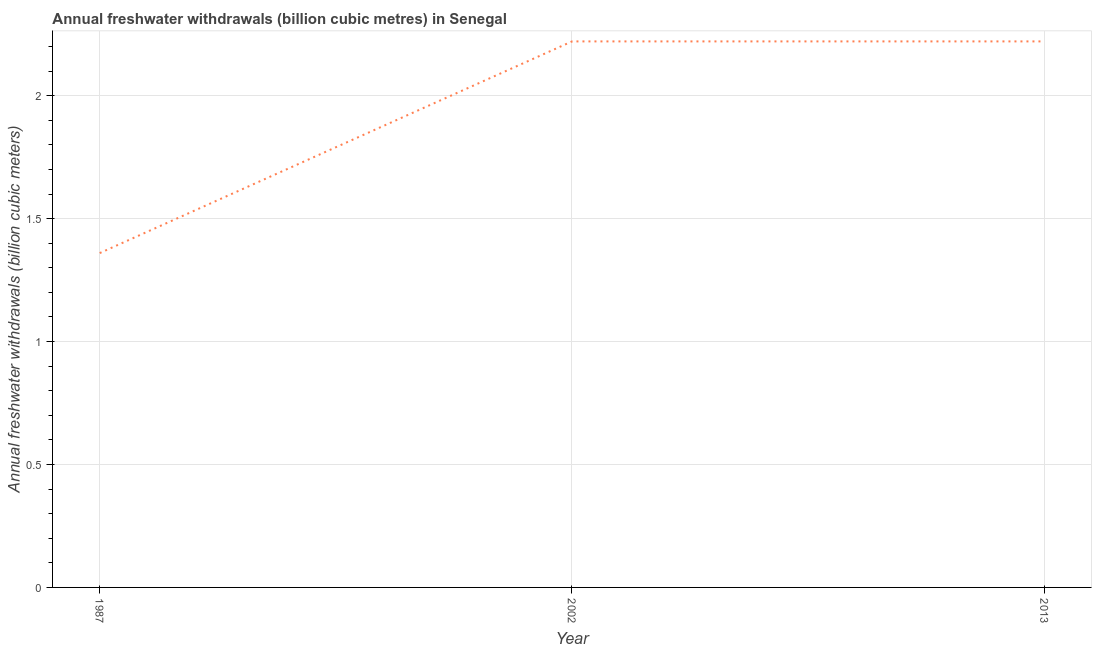What is the annual freshwater withdrawals in 2013?
Your response must be concise. 2.22. Across all years, what is the maximum annual freshwater withdrawals?
Your response must be concise. 2.22. Across all years, what is the minimum annual freshwater withdrawals?
Provide a short and direct response. 1.36. What is the sum of the annual freshwater withdrawals?
Keep it short and to the point. 5.8. What is the average annual freshwater withdrawals per year?
Offer a terse response. 1.93. What is the median annual freshwater withdrawals?
Ensure brevity in your answer.  2.22. What is the ratio of the annual freshwater withdrawals in 1987 to that in 2002?
Keep it short and to the point. 0.61. Is the annual freshwater withdrawals in 2002 less than that in 2013?
Give a very brief answer. No. Is the sum of the annual freshwater withdrawals in 1987 and 2013 greater than the maximum annual freshwater withdrawals across all years?
Make the answer very short. Yes. What is the difference between the highest and the lowest annual freshwater withdrawals?
Offer a very short reply. 0.86. Does the annual freshwater withdrawals monotonically increase over the years?
Give a very brief answer. No. How many lines are there?
Your answer should be compact. 1. How many years are there in the graph?
Keep it short and to the point. 3. What is the difference between two consecutive major ticks on the Y-axis?
Your response must be concise. 0.5. Are the values on the major ticks of Y-axis written in scientific E-notation?
Offer a very short reply. No. What is the title of the graph?
Your answer should be very brief. Annual freshwater withdrawals (billion cubic metres) in Senegal. What is the label or title of the Y-axis?
Provide a succinct answer. Annual freshwater withdrawals (billion cubic meters). What is the Annual freshwater withdrawals (billion cubic meters) of 1987?
Provide a short and direct response. 1.36. What is the Annual freshwater withdrawals (billion cubic meters) of 2002?
Your response must be concise. 2.22. What is the Annual freshwater withdrawals (billion cubic meters) in 2013?
Make the answer very short. 2.22. What is the difference between the Annual freshwater withdrawals (billion cubic meters) in 1987 and 2002?
Give a very brief answer. -0.86. What is the difference between the Annual freshwater withdrawals (billion cubic meters) in 1987 and 2013?
Give a very brief answer. -0.86. What is the ratio of the Annual freshwater withdrawals (billion cubic meters) in 1987 to that in 2002?
Provide a short and direct response. 0.61. What is the ratio of the Annual freshwater withdrawals (billion cubic meters) in 1987 to that in 2013?
Ensure brevity in your answer.  0.61. 